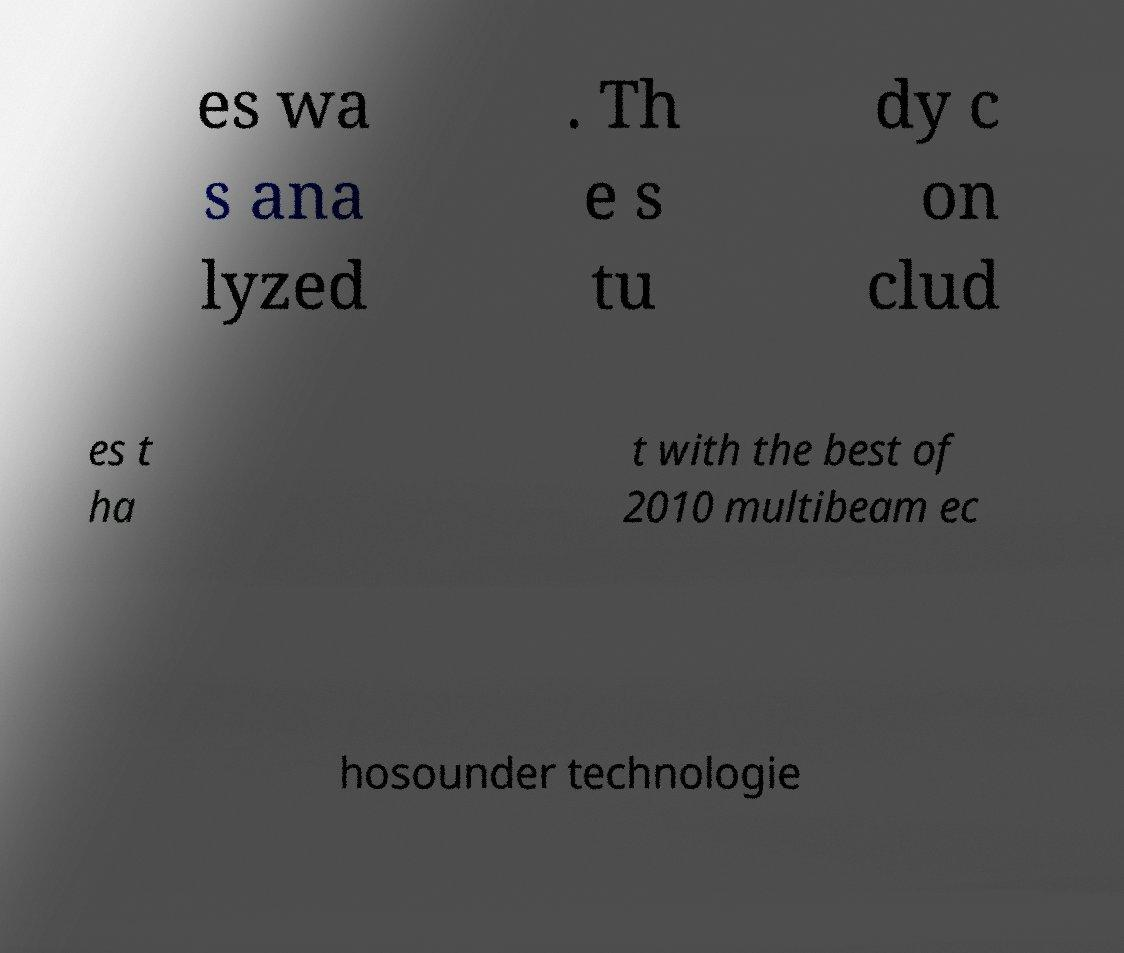Could you assist in decoding the text presented in this image and type it out clearly? es wa s ana lyzed . Th e s tu dy c on clud es t ha t with the best of 2010 multibeam ec hosounder technologie 